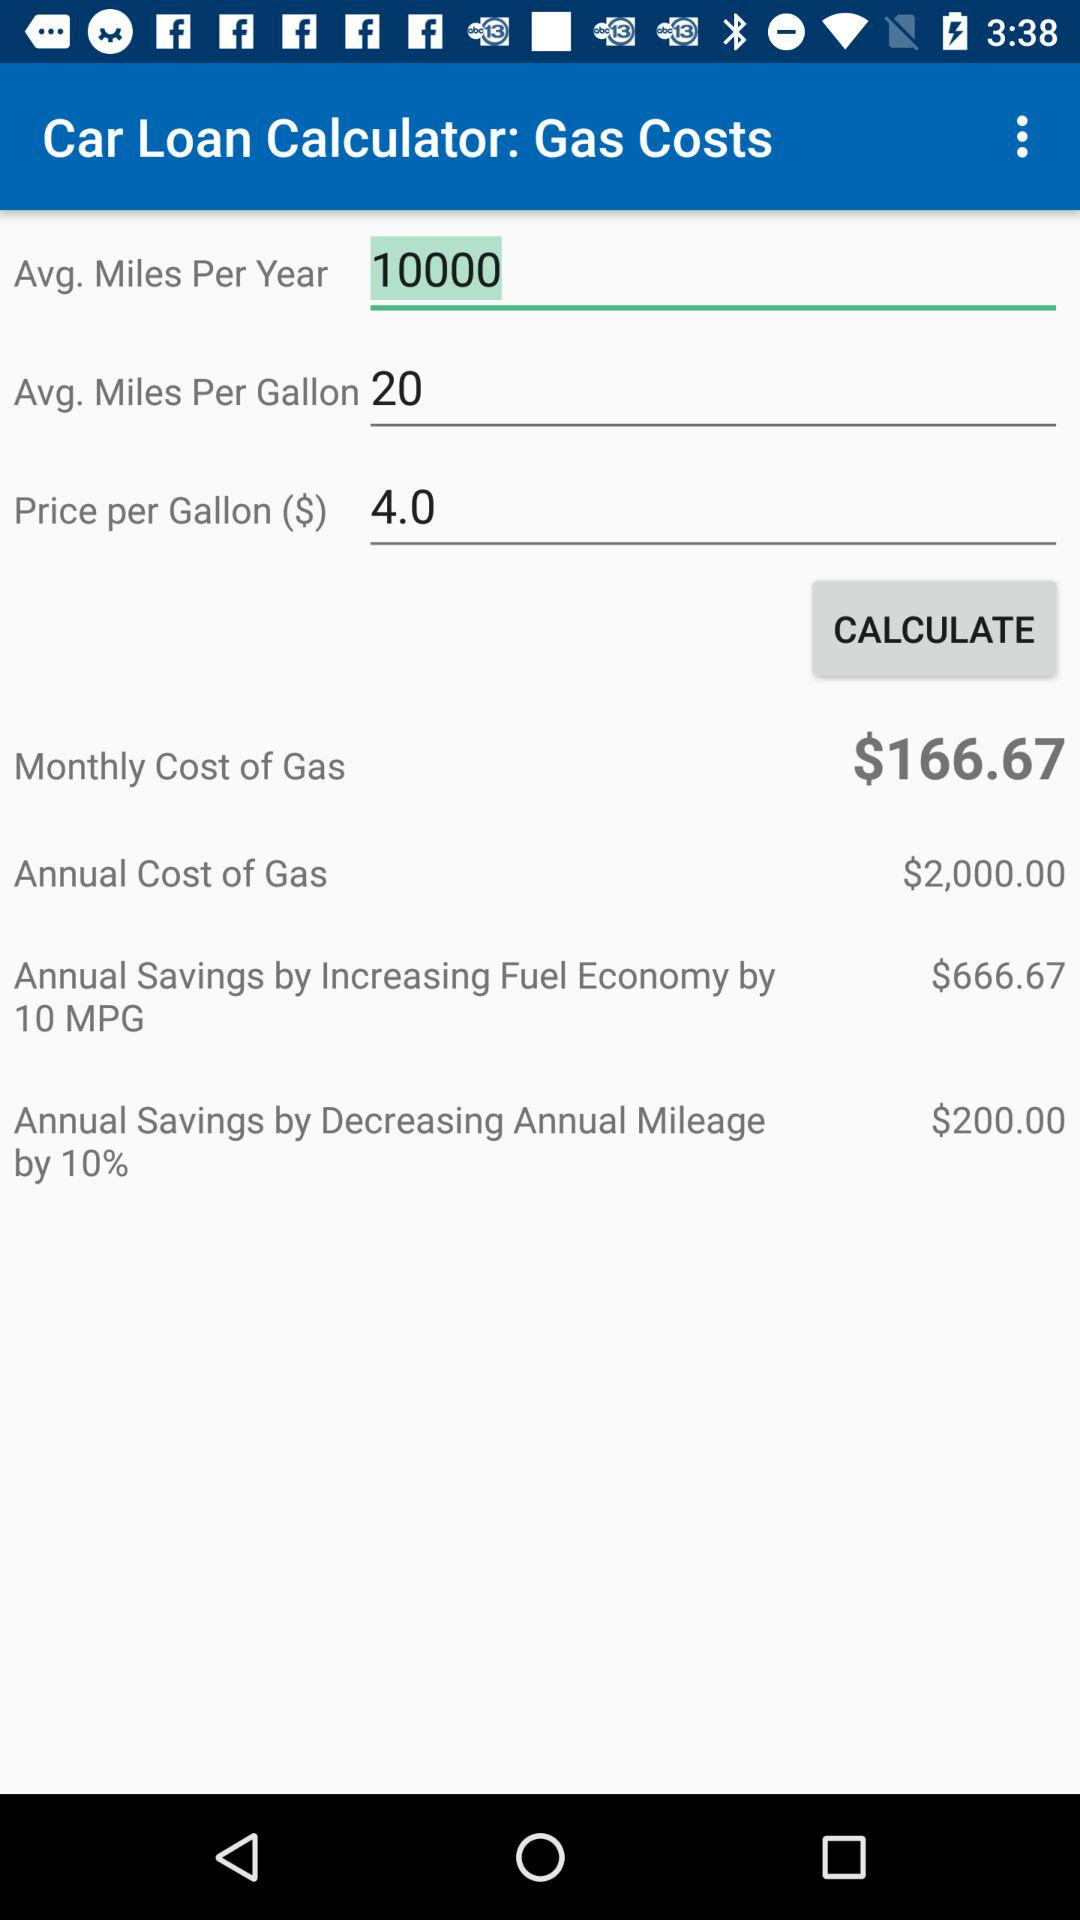What is the avg. miles per gallon? The avg. miles per gallon is 20. 